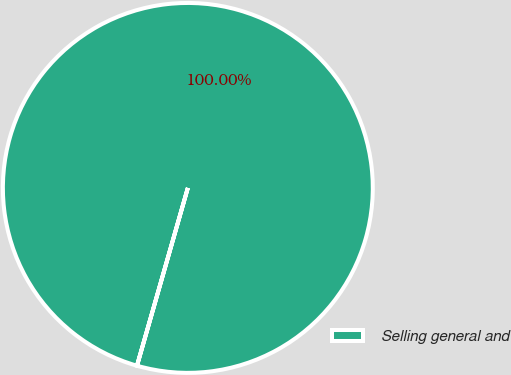Convert chart to OTSL. <chart><loc_0><loc_0><loc_500><loc_500><pie_chart><fcel>Selling general and<nl><fcel>100.0%<nl></chart> 